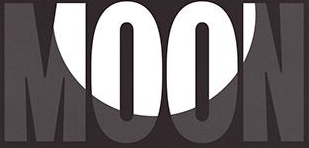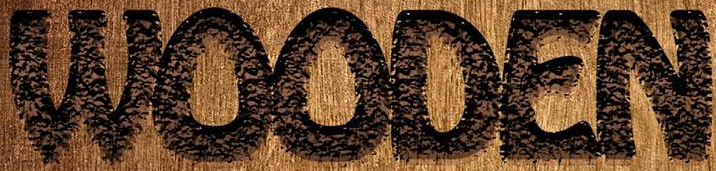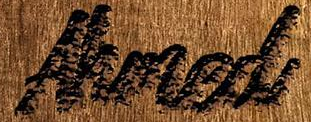What words can you see in these images in sequence, separated by a semicolon? MOON; WOODEN; Ahmed 